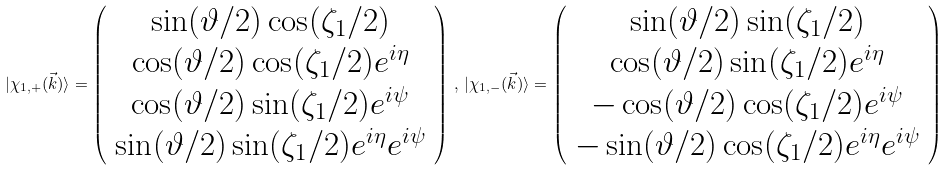<formula> <loc_0><loc_0><loc_500><loc_500>| \chi _ { 1 , + } ( \vec { k } ) \rangle = \left ( \begin{array} { c } \sin ( \vartheta / 2 ) \cos ( \zeta _ { 1 } / 2 ) \\ \cos ( \vartheta / 2 ) \cos ( \zeta _ { 1 } / 2 ) e ^ { i \eta } \\ \cos ( \vartheta / 2 ) \sin ( \zeta _ { 1 } / 2 ) e ^ { i \psi } \\ \sin ( \vartheta / 2 ) \sin ( \zeta _ { 1 } / 2 ) e ^ { i \eta } e ^ { i \psi } \end{array} \right ) \, , \, | \chi _ { 1 , - } ( \vec { k } ) \rangle = \left ( \begin{array} { c } \sin ( \vartheta / 2 ) \sin ( \zeta _ { 1 } / 2 ) \\ \cos ( \vartheta / 2 ) \sin ( \zeta _ { 1 } / 2 ) e ^ { i \eta } \\ - \cos ( \vartheta / 2 ) \cos ( \zeta _ { 1 } / 2 ) e ^ { i \psi } \\ - \sin ( \vartheta / 2 ) \cos ( \zeta _ { 1 } / 2 ) e ^ { i \eta } e ^ { i \psi } \end{array} \right )</formula> 